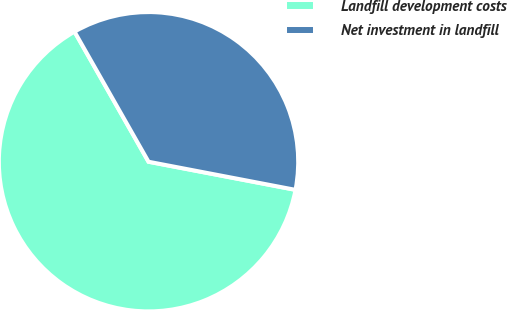Convert chart. <chart><loc_0><loc_0><loc_500><loc_500><pie_chart><fcel>Landfill development costs<fcel>Net investment in landfill<nl><fcel>63.76%<fcel>36.24%<nl></chart> 